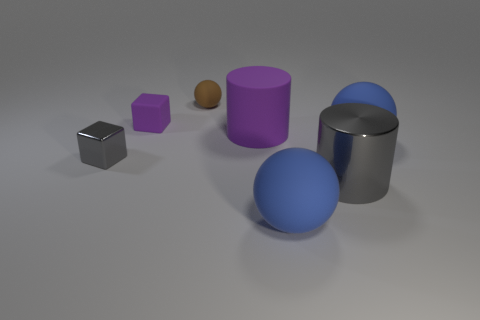There is a object that is made of the same material as the tiny gray cube; what is its size?
Offer a very short reply. Large. What number of tiny metal things are right of the tiny thing in front of the big purple thing?
Your answer should be compact. 0. Are the small object behind the rubber cube and the gray cylinder made of the same material?
Make the answer very short. No. Is there anything else that has the same material as the large gray cylinder?
Provide a short and direct response. Yes. How big is the gray thing that is to the right of the purple rubber object right of the small purple cube?
Give a very brief answer. Large. What is the size of the gray object in front of the tiny block that is in front of the purple thing that is left of the small brown rubber ball?
Ensure brevity in your answer.  Large. Does the blue rubber thing behind the large shiny object have the same shape as the large matte thing in front of the gray metallic cube?
Provide a succinct answer. Yes. How many other things are there of the same color as the metallic cylinder?
Your answer should be very brief. 1. Does the metal thing right of the rubber cylinder have the same size as the gray metal block?
Make the answer very short. No. Are the cylinder that is behind the gray shiny cylinder and the thing behind the small purple block made of the same material?
Ensure brevity in your answer.  Yes. 